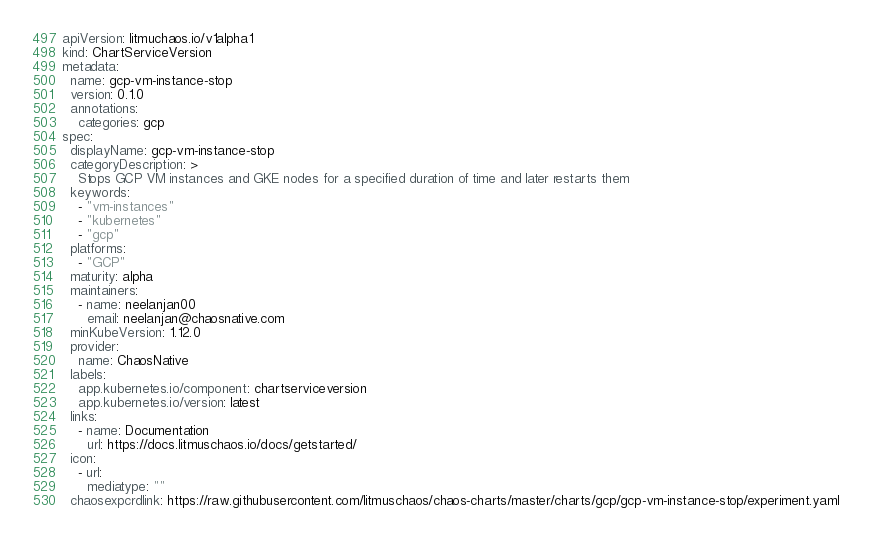<code> <loc_0><loc_0><loc_500><loc_500><_YAML_>apiVersion: litmuchaos.io/v1alpha1
kind: ChartServiceVersion
metadata:
  name: gcp-vm-instance-stop 
  version: 0.1.0
  annotations:
    categories: gcp
spec:
  displayName: gcp-vm-instance-stop 
  categoryDescription: >
    Stops GCP VM instances and GKE nodes for a specified duration of time and later restarts them 
  keywords: 
    - "vm-instances" 
    - "kubernetes" 
    - "gcp" 
  platforms: 
    - "GCP"
  maturity: alpha
  maintainers: 
    - name: neelanjan00 
      email: neelanjan@chaosnative.com 
  minKubeVersion: 1.12.0 
  provider: 
    name: ChaosNative
  labels:
    app.kubernetes.io/component: chartserviceversion
    app.kubernetes.io/version: latest
  links: 
    - name: Documentation 
      url: https://docs.litmuschaos.io/docs/getstarted/ 
  icon:
    - url: 
      mediatype: ""
  chaosexpcrdlink: https://raw.githubusercontent.com/litmuschaos/chaos-charts/master/charts/gcp/gcp-vm-instance-stop/experiment.yaml
</code> 